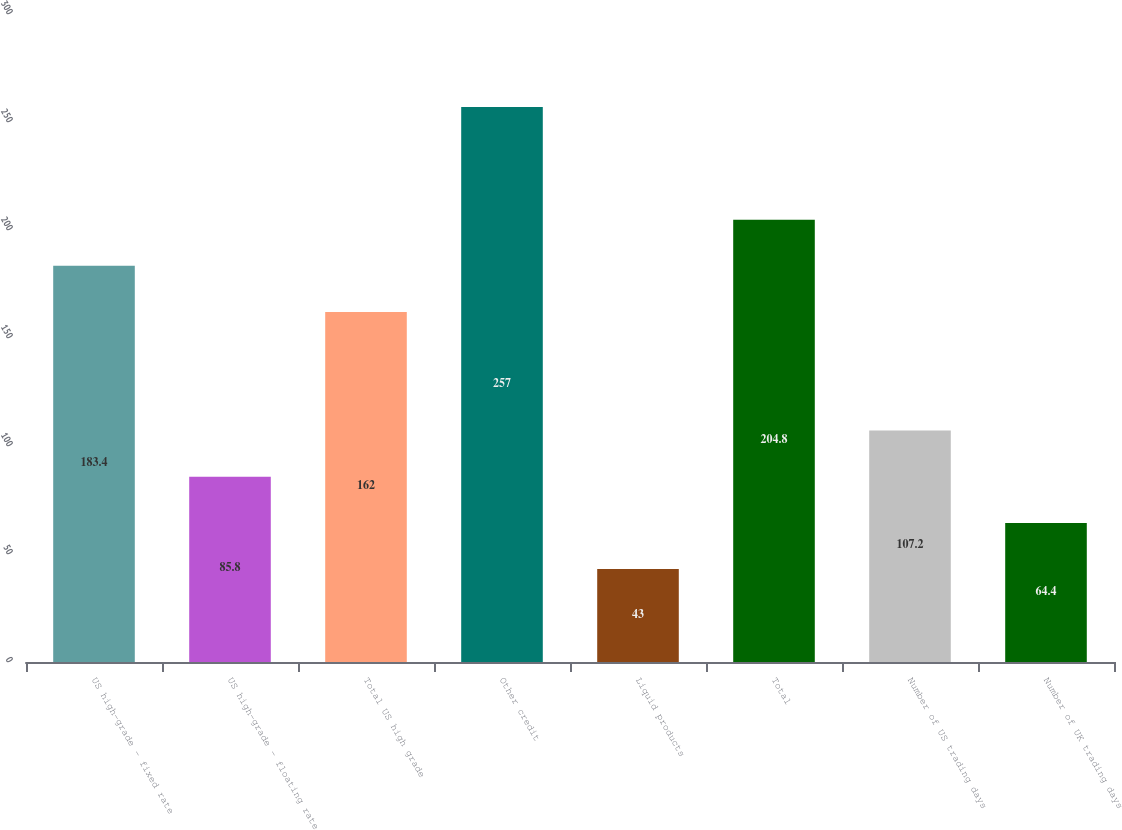<chart> <loc_0><loc_0><loc_500><loc_500><bar_chart><fcel>US high-grade - fixed rate<fcel>US high-grade - floating rate<fcel>Total US high grade<fcel>Other credit<fcel>Liquid products<fcel>Total<fcel>Number of US trading days<fcel>Number of UK trading days<nl><fcel>183.4<fcel>85.8<fcel>162<fcel>257<fcel>43<fcel>204.8<fcel>107.2<fcel>64.4<nl></chart> 